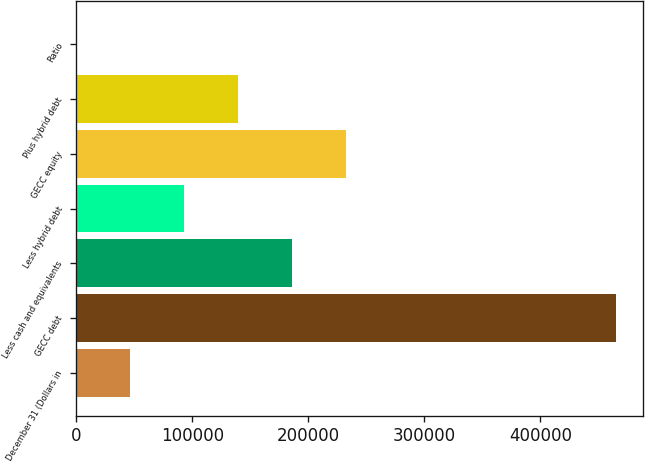Convert chart. <chart><loc_0><loc_0><loc_500><loc_500><bar_chart><fcel>December 31 (Dollars in<fcel>GECC debt<fcel>Less cash and equivalents<fcel>Less hybrid debt<fcel>GECC equity<fcel>Plus hybrid debt<fcel>Ratio<nl><fcel>46539.4<fcel>465350<fcel>186143<fcel>93074<fcel>232677<fcel>139608<fcel>4.94<nl></chart> 